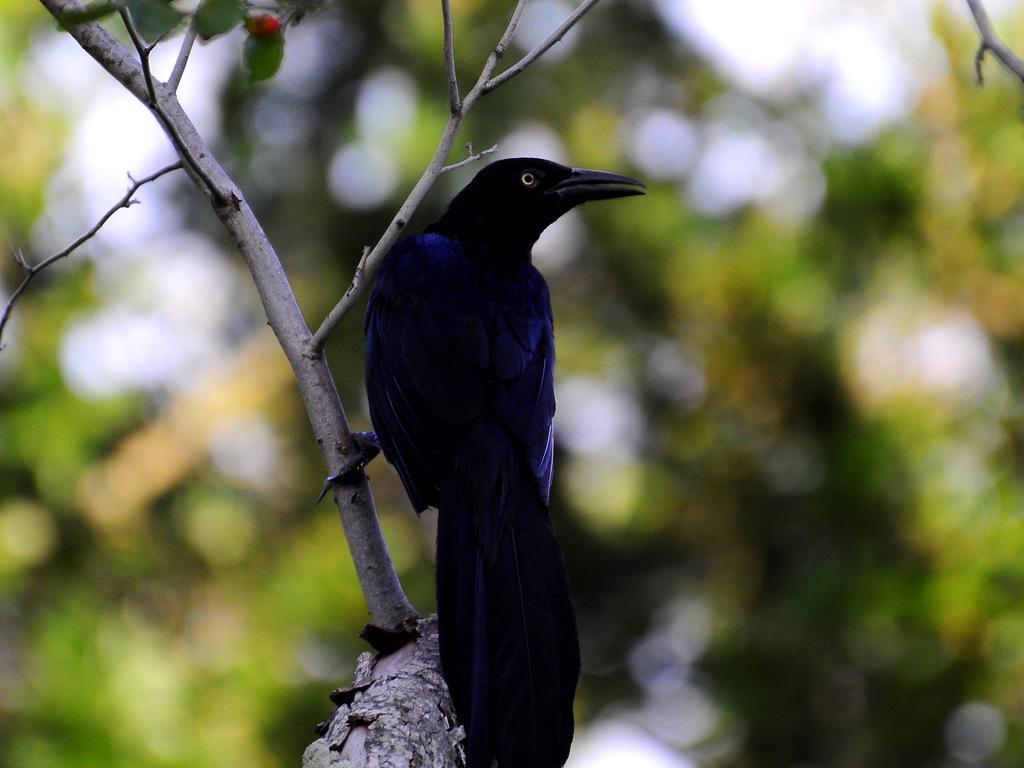Could you give a brief overview of what you see in this image? In this picture we can see a bird on the tree, in the background we can see few more trees. 